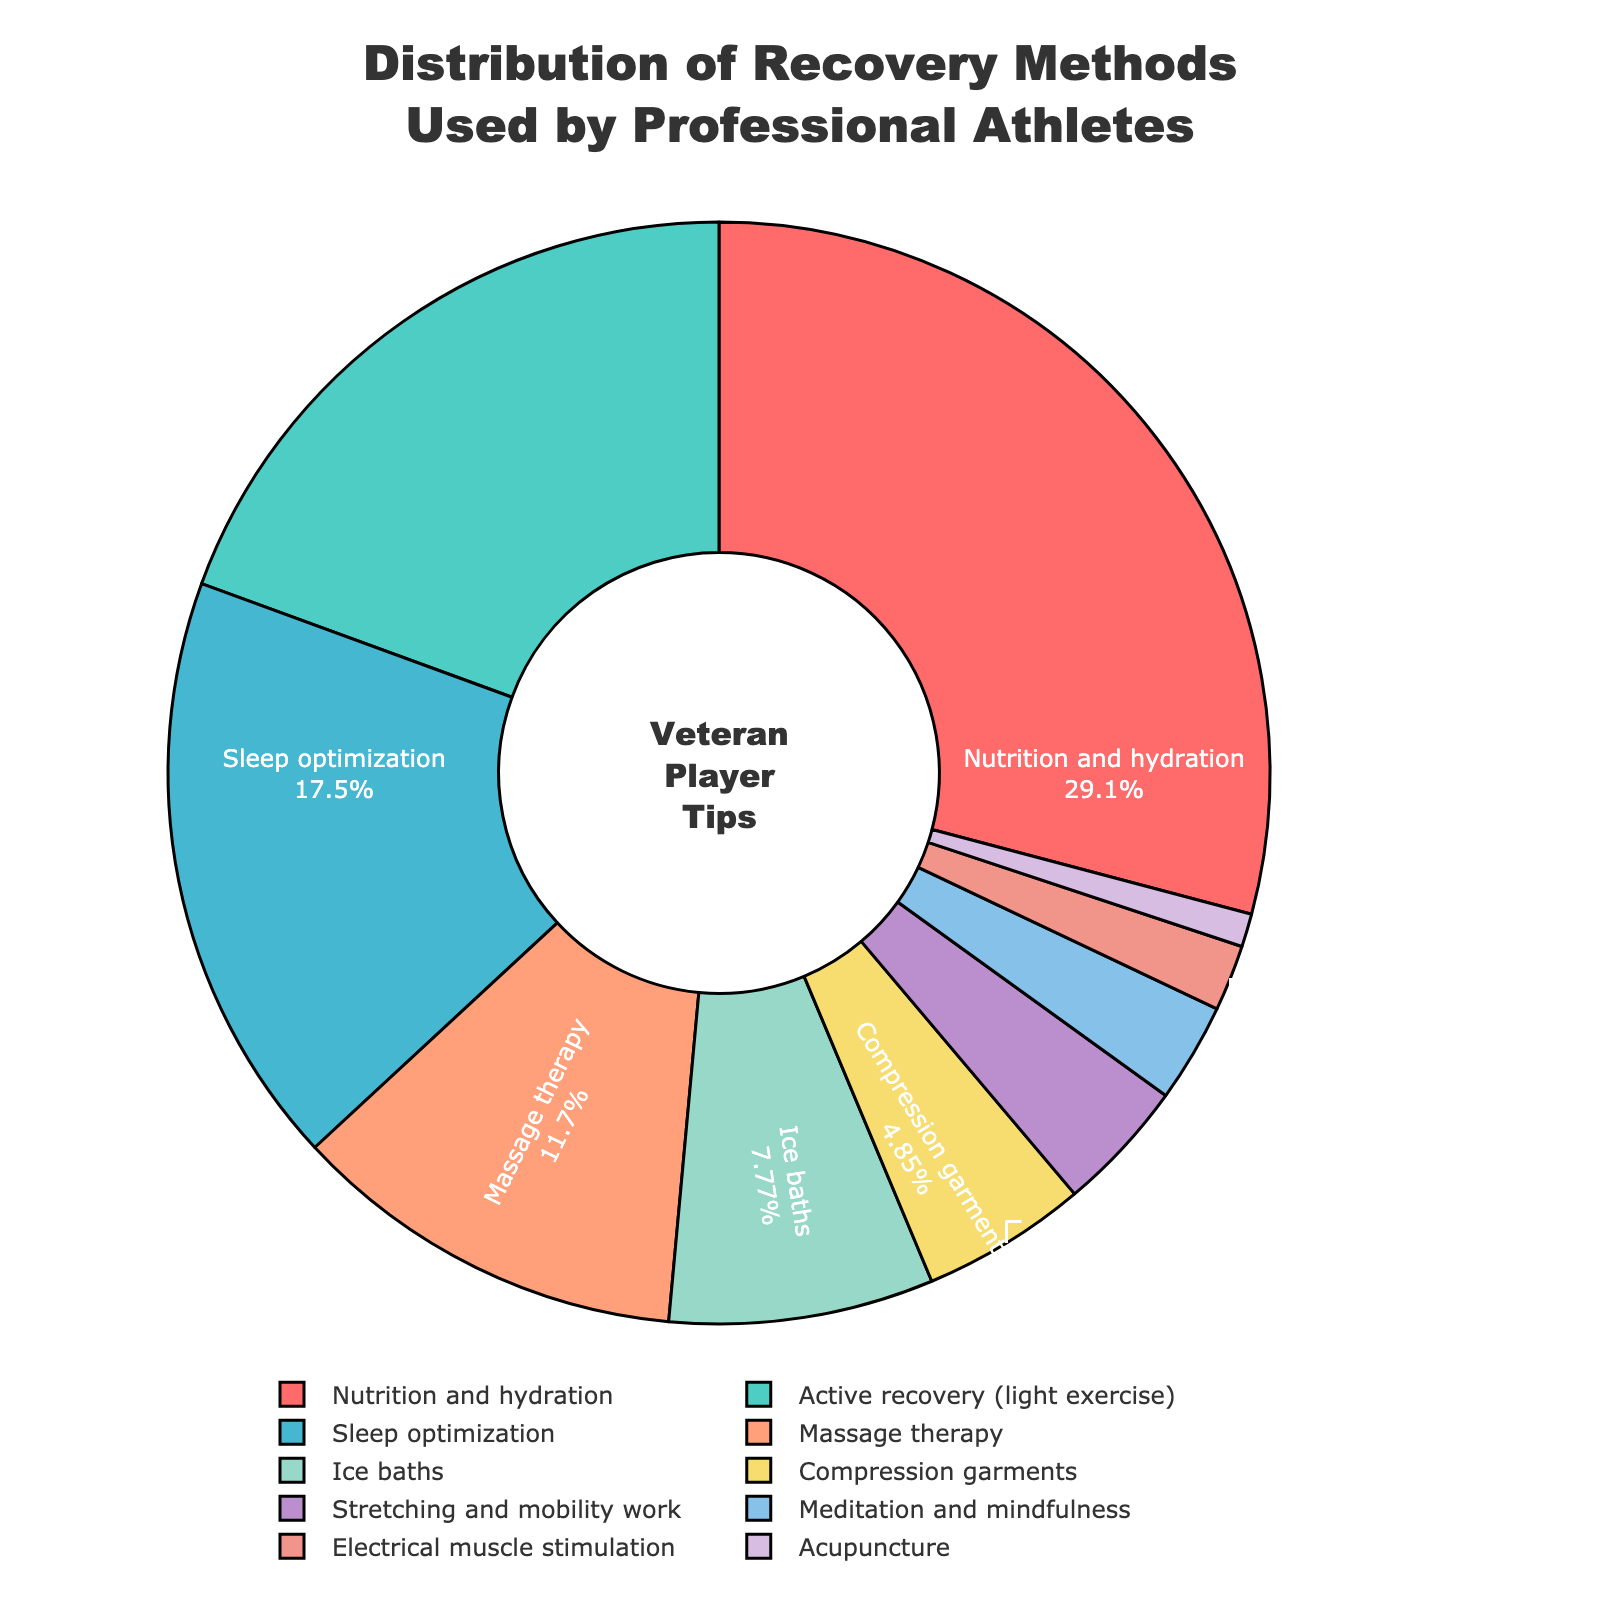What's the proportion of the total percentage do Nutrition and Hydration and Active Recovery account for together? Add the percentages of 'Nutrition and Hydration' (30%) and 'Active Recovery' (20%). The sum is 30 + 20 = 50% of the total.
Answer: 50% Which recovery method has the smallest percentage, and what is it? Look at the pie chart to find the smallest slice. 'Acupuncture' has the smallest percentage at 1%.
Answer: Acupuncture, 1% Are Sleep Optimization and Massage Therapy used equally by professional athletes? Compare the percentages of 'Sleep Optimization' (18%) and 'Massage Therapy' (12%). These percentages are not equal.
Answer: No Which recovery method occupies the largest portion of the pie chart? Observe the pie chart for the largest slice. 'Nutrition and Hydration' has the largest portion at 30%.
Answer: Nutrition and Hydration What's the combined total percentage of methods that involve physical activity (Active Recovery, Stretching and Mobility work)? Add the percentages for 'Active Recovery' (20%) and 'Stretching and Mobility work' (4%). The sum is 20 + 4 = 24%.
Answer: 24% What is the difference in percentage between Ice Baths and Compression Garments? Subtract the percentage of 'Compression Garments' (5%) from 'Ice Baths' (8%). The difference is 8 - 5 = 3%.
Answer: 3% Which has a higher percentage: Meditation and Mindfulness, or Electrical Muscle Stimulation? Compare the two percentages: 'Meditation and Mindfulness' (3%) and 'Electrical Muscle Stimulation' (2%). The former is higher.
Answer: Meditation and Mindfulness What percentage of recovery methods are considered relatively traditional (Massage Therapy and Ice Baths)? Add the percentages for 'Massage Therapy' (12%) and 'Ice Baths' (8%). The sum is 12 + 8 = 20%.
Answer: 20% How many recovery methods have a percentage greater than 10%? Identify and count the methods with percentages over 10%: 'Nutrition and Hydration' (30%), 'Active Recovery' (20%), 'Sleep Optimization' (18%), and 'Massage Therapy' (12%). There are 4.
Answer: 4 Are there more recovery methods with percentages below 5% or equal to or above 5%? Count the recovery methods below 5%: 'Stretching and Mobility work' (4%), 'Meditation and Mindfulness' (3%), 'Electrical Muscle Stimulation' (2%), 'Acupuncture' (1%) (4 total). Count those equal to or above 5%: 'Nutrition and Hydration' (30%), 'Active Recovery' (20%), 'Sleep Optimization' (18%), 'Massage Therapy' (12%), 'Ice Baths' (8%), 'Compression Garments' (5%) (6 total). There are more equal to or above 5%.
Answer: Equal to or above 5% 